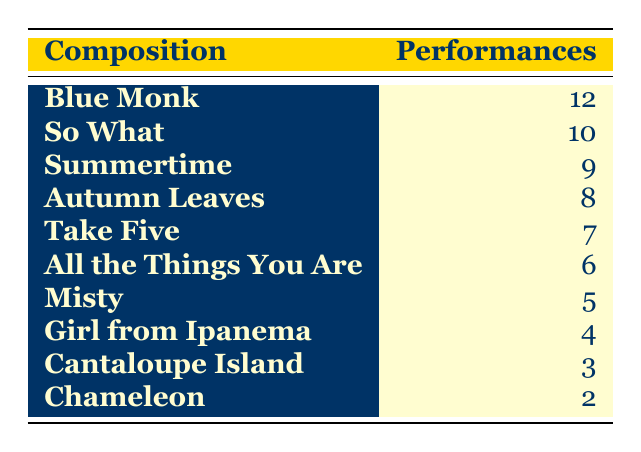What composition has the highest number of performances? The table shows the performances for each composition. By looking at the numbers, "Blue Monk" has the highest performances with 12.
Answer: Blue Monk How many performances were made for "So What"? According to the table, "So What" has 10 performances listed.
Answer: 10 Is "Summertime" performed more than "Take Five"? The table indicates that "Summertime" has 9 performances while "Take Five" has 7. Therefore, "Summertime" is performed more than "Take Five".
Answer: Yes What is the total number of performances for the compositions listed? To find the total, we add all performances: 12 + 10 + 9 + 8 + 7 + 6 + 5 + 4 + 3 + 2 = 66.
Answer: 66 Which composition has the least performances? The compositions are listed with their performances, and "Chameleon" has the lowest number of performances, with only 2.
Answer: Chameleon Calculate the average number of performances across all compositions. There are 10 compositions, and the sum of performances is 66. To find the average, we divide 66 by 10, resulting in an average of 6.6.
Answer: 6.6 Is "Girl from Ipanema" performed more than "Misty"? "Girl from Ipanema" has 4 performances, while "Misty" has 5. Thus, "Girl from Ipanema" is not performed more than "Misty".
Answer: No Which two compositions together have performances totaling 19? From the table, "Blue Monk" (12) and "So What" (10) give a total of 22, "Summertime" (9) and "Autumn Leaves" (8) give a total of 17. But "So What" (10) and "Misty" (5) equal 15. The correct combination is "Autumn Leaves" (8) with "Take Five" (7) totaling 15; however, no combinations total 19.
Answer: None How many compositions have performed 6 times or more? By examining the table, the compositions that meet this criterion are "Blue Monk", "So What", "Summertime", "Autumn Leaves", "Take Five", and "All the Things You Are". So there are 6 compositions.
Answer: 6 